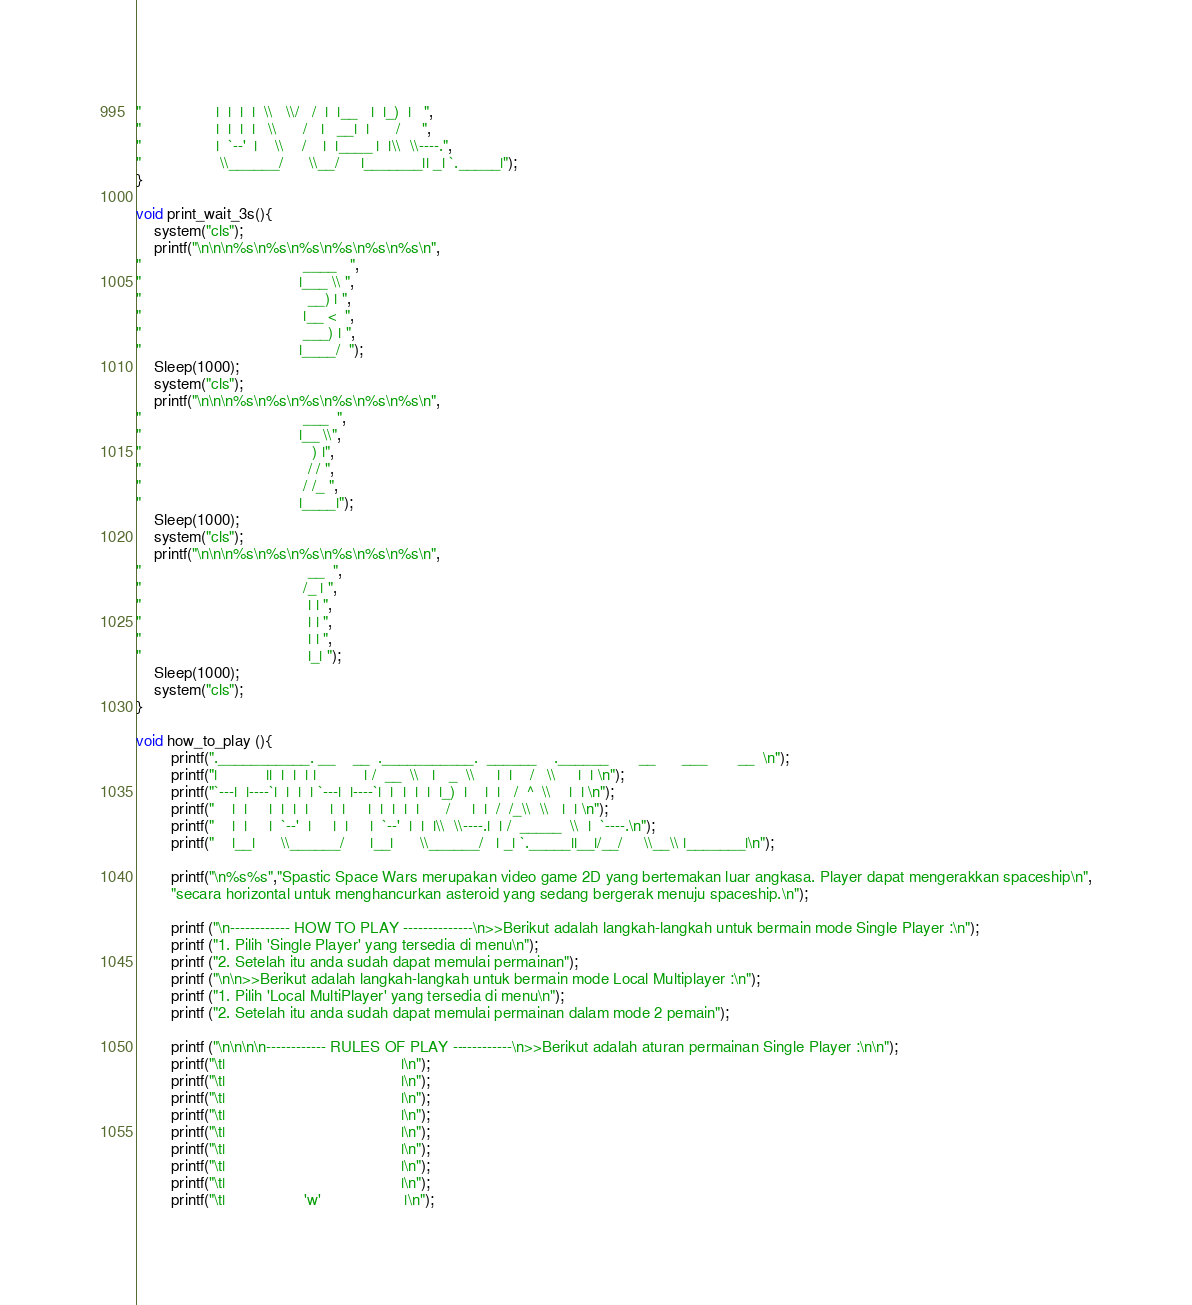Convert code to text. <code><loc_0><loc_0><loc_500><loc_500><_C_>"                 |  |  |  |  \\   \\/   /  |  |__   |  |_)  |   ",
"                 |  |  |  |   \\      /   |   __|  |      /     ",
"                 |  `--'  |    \\    /    |  |____ |  |\\  \\----.",
"                  \\______/      \\__/     |_______|| _| `._____|");
}

void print_wait_3s(){
	system("cls");
	printf("\n\n\n%s\n%s\n%s\n%s\n%s\n%s\n",
"                                     ____   ",
"                                    |___ \\ ",
"                                      __) | ",
"                                     |__ <  ",
"                                     ___) | ",
"                                    |____/  ");
	Sleep(1000);
	system("cls");
	printf("\n\n\n%s\n%s\n%s\n%s\n%s\n%s\n",
"                                     ___  ", 
"                                    |__ \\",  
"                                       ) |", 
"                                      / / ", 
"                                     / /_ ", 
"                                    |____|"); 
	Sleep(1000);
	system("cls");
	printf("\n\n\n%s\n%s\n%s\n%s\n%s\n%s\n",
"                                      __  ",
"                                     /_ | ",
"                                      | | ",
"                                      | | ",
"                                      | | ",
"                                      |_| ");
	Sleep(1000);
	system("cls");
}

void how_to_play (){
		printf(".___________. __    __  .___________.  ______    .______       __      ___       __  \n");
		printf("|           ||  |  |  | |           | /  __  \\   |   _  \\     |  |    /   \\     |  | \n");
		printf("`---|  |----`|  |  |  | `---|  |----`|  |  |  |  |  |_)  |    |  |   /  ^  \\    |  | \n");
		printf("    |  |     |  |  |  |     |  |     |  |  |  |  |      /     |  |  /  /_\\  \\   |  | \n");
		printf("    |  |     |  `--'  |     |  |     |  `--'  |  |  |\\  \\----.|  | /  _____  \\  |  `----.\n");
		printf("    |__|      \\______/      |__|      \\______/   | _| `._____||__|/__/     \\__\\ |_______|\n");
	
		printf("\n%s%s","Spastic Space Wars merupakan video game 2D yang bertemakan luar angkasa. Player dapat mengerakkan spaceship\n",
		"secara horizontal untuk menghancurkan asteroid yang sedang bergerak menuju spaceship.\n");
	
		printf ("\n------------ HOW TO PLAY --------------\n>>Berikut adalah langkah-langkah untuk bermain mode Single Player :\n");
		printf ("1. Pilih 'Single Player' yang tersedia di menu\n");
		printf ("2. Setelah itu anda sudah dapat memulai permainan");
		printf ("\n\n>>Berikut adalah langkah-langkah untuk bermain mode Local Multiplayer :\n");
		printf ("1. Pilih 'Local MultiPlayer' yang tersedia di menu\n");
		printf ("2. Setelah itu anda sudah dapat memulai permainan dalam mode 2 pemain");
	
		printf ("\n\n\n\n------------ RULES OF PLAY ------------\n>>Berikut adalah aturan permainan Single Player :\n\n");
		printf("\t|                                        |\n");
		printf("\t|                                        |\n");
		printf("\t|                                        |\n");
		printf("\t|                                        |\n");
		printf("\t|                                        |\n");
		printf("\t|                                        |\n");
		printf("\t|                                        |\n");
		printf("\t|                                        |\n");
		printf("\t|                  'w'                   |\n");</code> 